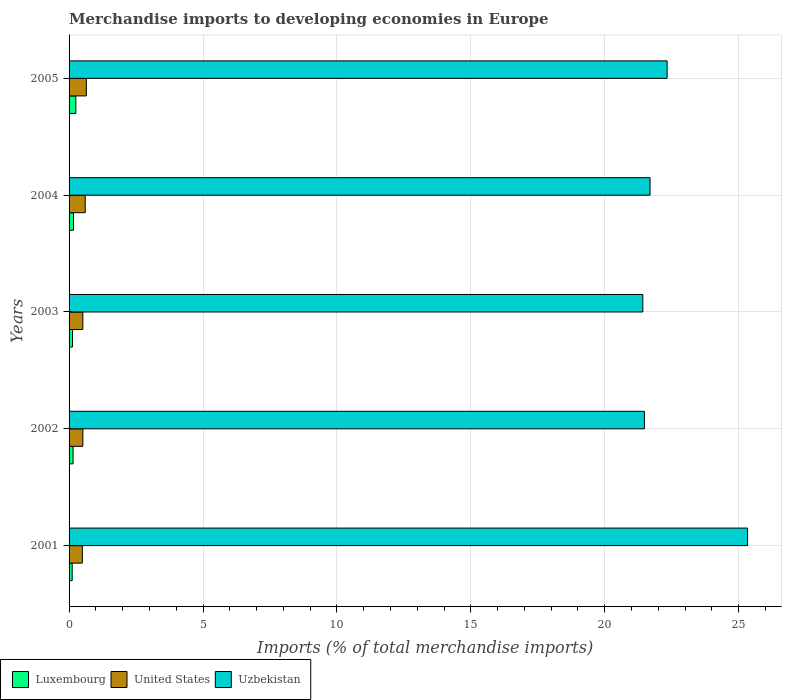Are the number of bars per tick equal to the number of legend labels?
Offer a very short reply. Yes. How many bars are there on the 3rd tick from the bottom?
Your response must be concise. 3. In how many cases, is the number of bars for a given year not equal to the number of legend labels?
Give a very brief answer. 0. What is the percentage total merchandise imports in Luxembourg in 2001?
Offer a very short reply. 0.12. Across all years, what is the maximum percentage total merchandise imports in United States?
Make the answer very short. 0.65. Across all years, what is the minimum percentage total merchandise imports in United States?
Give a very brief answer. 0.5. In which year was the percentage total merchandise imports in United States maximum?
Your answer should be compact. 2005. What is the total percentage total merchandise imports in United States in the graph?
Your response must be concise. 2.77. What is the difference between the percentage total merchandise imports in United States in 2001 and that in 2002?
Make the answer very short. -0.02. What is the difference between the percentage total merchandise imports in Luxembourg in 2001 and the percentage total merchandise imports in United States in 2002?
Give a very brief answer. -0.4. What is the average percentage total merchandise imports in United States per year?
Your response must be concise. 0.55. In the year 2002, what is the difference between the percentage total merchandise imports in Luxembourg and percentage total merchandise imports in United States?
Your answer should be compact. -0.37. What is the ratio of the percentage total merchandise imports in Uzbekistan in 2001 to that in 2004?
Give a very brief answer. 1.17. Is the difference between the percentage total merchandise imports in Luxembourg in 2002 and 2005 greater than the difference between the percentage total merchandise imports in United States in 2002 and 2005?
Offer a terse response. Yes. What is the difference between the highest and the second highest percentage total merchandise imports in Uzbekistan?
Offer a very short reply. 3. What is the difference between the highest and the lowest percentage total merchandise imports in Uzbekistan?
Your answer should be very brief. 3.91. In how many years, is the percentage total merchandise imports in Uzbekistan greater than the average percentage total merchandise imports in Uzbekistan taken over all years?
Offer a very short reply. 1. Is the sum of the percentage total merchandise imports in United States in 2001 and 2002 greater than the maximum percentage total merchandise imports in Luxembourg across all years?
Offer a terse response. Yes. What does the 3rd bar from the top in 2003 represents?
Your answer should be compact. Luxembourg. What does the 1st bar from the bottom in 2003 represents?
Your answer should be very brief. Luxembourg. How many bars are there?
Give a very brief answer. 15. Are all the bars in the graph horizontal?
Your answer should be compact. Yes. Does the graph contain any zero values?
Your answer should be compact. No. Where does the legend appear in the graph?
Ensure brevity in your answer.  Bottom left. What is the title of the graph?
Your answer should be compact. Merchandise imports to developing economies in Europe. What is the label or title of the X-axis?
Offer a terse response. Imports (% of total merchandise imports). What is the label or title of the Y-axis?
Give a very brief answer. Years. What is the Imports (% of total merchandise imports) of Luxembourg in 2001?
Keep it short and to the point. 0.12. What is the Imports (% of total merchandise imports) of United States in 2001?
Provide a short and direct response. 0.5. What is the Imports (% of total merchandise imports) of Uzbekistan in 2001?
Your answer should be very brief. 25.33. What is the Imports (% of total merchandise imports) in Luxembourg in 2002?
Offer a terse response. 0.15. What is the Imports (% of total merchandise imports) in United States in 2002?
Your response must be concise. 0.52. What is the Imports (% of total merchandise imports) of Uzbekistan in 2002?
Your answer should be very brief. 21.48. What is the Imports (% of total merchandise imports) of Luxembourg in 2003?
Offer a very short reply. 0.13. What is the Imports (% of total merchandise imports) in United States in 2003?
Offer a terse response. 0.51. What is the Imports (% of total merchandise imports) of Uzbekistan in 2003?
Provide a succinct answer. 21.42. What is the Imports (% of total merchandise imports) of Luxembourg in 2004?
Your answer should be compact. 0.16. What is the Imports (% of total merchandise imports) in United States in 2004?
Provide a succinct answer. 0.6. What is the Imports (% of total merchandise imports) of Uzbekistan in 2004?
Ensure brevity in your answer.  21.69. What is the Imports (% of total merchandise imports) of Luxembourg in 2005?
Give a very brief answer. 0.25. What is the Imports (% of total merchandise imports) of United States in 2005?
Provide a succinct answer. 0.65. What is the Imports (% of total merchandise imports) in Uzbekistan in 2005?
Ensure brevity in your answer.  22.33. Across all years, what is the maximum Imports (% of total merchandise imports) of Luxembourg?
Make the answer very short. 0.25. Across all years, what is the maximum Imports (% of total merchandise imports) in United States?
Provide a succinct answer. 0.65. Across all years, what is the maximum Imports (% of total merchandise imports) of Uzbekistan?
Offer a very short reply. 25.33. Across all years, what is the minimum Imports (% of total merchandise imports) of Luxembourg?
Make the answer very short. 0.12. Across all years, what is the minimum Imports (% of total merchandise imports) of United States?
Your answer should be very brief. 0.5. Across all years, what is the minimum Imports (% of total merchandise imports) in Uzbekistan?
Make the answer very short. 21.42. What is the total Imports (% of total merchandise imports) in Luxembourg in the graph?
Your answer should be very brief. 0.81. What is the total Imports (% of total merchandise imports) of United States in the graph?
Ensure brevity in your answer.  2.77. What is the total Imports (% of total merchandise imports) in Uzbekistan in the graph?
Your answer should be very brief. 112.25. What is the difference between the Imports (% of total merchandise imports) in Luxembourg in 2001 and that in 2002?
Your answer should be very brief. -0.03. What is the difference between the Imports (% of total merchandise imports) in United States in 2001 and that in 2002?
Offer a terse response. -0.02. What is the difference between the Imports (% of total merchandise imports) of Uzbekistan in 2001 and that in 2002?
Keep it short and to the point. 3.85. What is the difference between the Imports (% of total merchandise imports) of Luxembourg in 2001 and that in 2003?
Your response must be concise. -0.01. What is the difference between the Imports (% of total merchandise imports) of United States in 2001 and that in 2003?
Your answer should be compact. -0.02. What is the difference between the Imports (% of total merchandise imports) of Uzbekistan in 2001 and that in 2003?
Provide a short and direct response. 3.91. What is the difference between the Imports (% of total merchandise imports) in Luxembourg in 2001 and that in 2004?
Your response must be concise. -0.05. What is the difference between the Imports (% of total merchandise imports) in United States in 2001 and that in 2004?
Offer a terse response. -0.11. What is the difference between the Imports (% of total merchandise imports) of Uzbekistan in 2001 and that in 2004?
Your answer should be very brief. 3.64. What is the difference between the Imports (% of total merchandise imports) in Luxembourg in 2001 and that in 2005?
Your answer should be compact. -0.14. What is the difference between the Imports (% of total merchandise imports) of United States in 2001 and that in 2005?
Your response must be concise. -0.15. What is the difference between the Imports (% of total merchandise imports) in Uzbekistan in 2001 and that in 2005?
Give a very brief answer. 3. What is the difference between the Imports (% of total merchandise imports) in Luxembourg in 2002 and that in 2003?
Provide a succinct answer. 0.02. What is the difference between the Imports (% of total merchandise imports) of United States in 2002 and that in 2003?
Provide a succinct answer. 0. What is the difference between the Imports (% of total merchandise imports) in Uzbekistan in 2002 and that in 2003?
Give a very brief answer. 0.06. What is the difference between the Imports (% of total merchandise imports) in Luxembourg in 2002 and that in 2004?
Offer a terse response. -0.02. What is the difference between the Imports (% of total merchandise imports) in United States in 2002 and that in 2004?
Keep it short and to the point. -0.09. What is the difference between the Imports (% of total merchandise imports) in Uzbekistan in 2002 and that in 2004?
Your answer should be compact. -0.21. What is the difference between the Imports (% of total merchandise imports) of Luxembourg in 2002 and that in 2005?
Provide a succinct answer. -0.1. What is the difference between the Imports (% of total merchandise imports) of United States in 2002 and that in 2005?
Your answer should be very brief. -0.13. What is the difference between the Imports (% of total merchandise imports) in Uzbekistan in 2002 and that in 2005?
Offer a terse response. -0.85. What is the difference between the Imports (% of total merchandise imports) in Luxembourg in 2003 and that in 2004?
Your response must be concise. -0.04. What is the difference between the Imports (% of total merchandise imports) of United States in 2003 and that in 2004?
Offer a terse response. -0.09. What is the difference between the Imports (% of total merchandise imports) of Uzbekistan in 2003 and that in 2004?
Make the answer very short. -0.27. What is the difference between the Imports (% of total merchandise imports) in Luxembourg in 2003 and that in 2005?
Provide a succinct answer. -0.12. What is the difference between the Imports (% of total merchandise imports) in United States in 2003 and that in 2005?
Provide a succinct answer. -0.13. What is the difference between the Imports (% of total merchandise imports) in Uzbekistan in 2003 and that in 2005?
Your answer should be very brief. -0.91. What is the difference between the Imports (% of total merchandise imports) of Luxembourg in 2004 and that in 2005?
Offer a very short reply. -0.09. What is the difference between the Imports (% of total merchandise imports) of United States in 2004 and that in 2005?
Your answer should be compact. -0.04. What is the difference between the Imports (% of total merchandise imports) in Uzbekistan in 2004 and that in 2005?
Keep it short and to the point. -0.64. What is the difference between the Imports (% of total merchandise imports) of Luxembourg in 2001 and the Imports (% of total merchandise imports) of United States in 2002?
Your answer should be very brief. -0.4. What is the difference between the Imports (% of total merchandise imports) in Luxembourg in 2001 and the Imports (% of total merchandise imports) in Uzbekistan in 2002?
Give a very brief answer. -21.36. What is the difference between the Imports (% of total merchandise imports) in United States in 2001 and the Imports (% of total merchandise imports) in Uzbekistan in 2002?
Provide a short and direct response. -20.99. What is the difference between the Imports (% of total merchandise imports) in Luxembourg in 2001 and the Imports (% of total merchandise imports) in United States in 2003?
Ensure brevity in your answer.  -0.4. What is the difference between the Imports (% of total merchandise imports) in Luxembourg in 2001 and the Imports (% of total merchandise imports) in Uzbekistan in 2003?
Offer a terse response. -21.3. What is the difference between the Imports (% of total merchandise imports) of United States in 2001 and the Imports (% of total merchandise imports) of Uzbekistan in 2003?
Provide a succinct answer. -20.93. What is the difference between the Imports (% of total merchandise imports) of Luxembourg in 2001 and the Imports (% of total merchandise imports) of United States in 2004?
Offer a terse response. -0.49. What is the difference between the Imports (% of total merchandise imports) in Luxembourg in 2001 and the Imports (% of total merchandise imports) in Uzbekistan in 2004?
Offer a very short reply. -21.57. What is the difference between the Imports (% of total merchandise imports) of United States in 2001 and the Imports (% of total merchandise imports) of Uzbekistan in 2004?
Provide a short and direct response. -21.2. What is the difference between the Imports (% of total merchandise imports) in Luxembourg in 2001 and the Imports (% of total merchandise imports) in United States in 2005?
Your answer should be compact. -0.53. What is the difference between the Imports (% of total merchandise imports) of Luxembourg in 2001 and the Imports (% of total merchandise imports) of Uzbekistan in 2005?
Ensure brevity in your answer.  -22.21. What is the difference between the Imports (% of total merchandise imports) in United States in 2001 and the Imports (% of total merchandise imports) in Uzbekistan in 2005?
Your response must be concise. -21.83. What is the difference between the Imports (% of total merchandise imports) in Luxembourg in 2002 and the Imports (% of total merchandise imports) in United States in 2003?
Offer a very short reply. -0.36. What is the difference between the Imports (% of total merchandise imports) in Luxembourg in 2002 and the Imports (% of total merchandise imports) in Uzbekistan in 2003?
Give a very brief answer. -21.27. What is the difference between the Imports (% of total merchandise imports) in United States in 2002 and the Imports (% of total merchandise imports) in Uzbekistan in 2003?
Ensure brevity in your answer.  -20.91. What is the difference between the Imports (% of total merchandise imports) of Luxembourg in 2002 and the Imports (% of total merchandise imports) of United States in 2004?
Make the answer very short. -0.45. What is the difference between the Imports (% of total merchandise imports) in Luxembourg in 2002 and the Imports (% of total merchandise imports) in Uzbekistan in 2004?
Keep it short and to the point. -21.54. What is the difference between the Imports (% of total merchandise imports) in United States in 2002 and the Imports (% of total merchandise imports) in Uzbekistan in 2004?
Make the answer very short. -21.18. What is the difference between the Imports (% of total merchandise imports) in Luxembourg in 2002 and the Imports (% of total merchandise imports) in United States in 2005?
Offer a terse response. -0.5. What is the difference between the Imports (% of total merchandise imports) in Luxembourg in 2002 and the Imports (% of total merchandise imports) in Uzbekistan in 2005?
Make the answer very short. -22.18. What is the difference between the Imports (% of total merchandise imports) in United States in 2002 and the Imports (% of total merchandise imports) in Uzbekistan in 2005?
Give a very brief answer. -21.81. What is the difference between the Imports (% of total merchandise imports) of Luxembourg in 2003 and the Imports (% of total merchandise imports) of United States in 2004?
Make the answer very short. -0.47. What is the difference between the Imports (% of total merchandise imports) of Luxembourg in 2003 and the Imports (% of total merchandise imports) of Uzbekistan in 2004?
Give a very brief answer. -21.56. What is the difference between the Imports (% of total merchandise imports) of United States in 2003 and the Imports (% of total merchandise imports) of Uzbekistan in 2004?
Offer a very short reply. -21.18. What is the difference between the Imports (% of total merchandise imports) in Luxembourg in 2003 and the Imports (% of total merchandise imports) in United States in 2005?
Ensure brevity in your answer.  -0.52. What is the difference between the Imports (% of total merchandise imports) of Luxembourg in 2003 and the Imports (% of total merchandise imports) of Uzbekistan in 2005?
Make the answer very short. -22.2. What is the difference between the Imports (% of total merchandise imports) of United States in 2003 and the Imports (% of total merchandise imports) of Uzbekistan in 2005?
Give a very brief answer. -21.81. What is the difference between the Imports (% of total merchandise imports) in Luxembourg in 2004 and the Imports (% of total merchandise imports) in United States in 2005?
Offer a very short reply. -0.48. What is the difference between the Imports (% of total merchandise imports) in Luxembourg in 2004 and the Imports (% of total merchandise imports) in Uzbekistan in 2005?
Your answer should be compact. -22.16. What is the difference between the Imports (% of total merchandise imports) in United States in 2004 and the Imports (% of total merchandise imports) in Uzbekistan in 2005?
Provide a short and direct response. -21.73. What is the average Imports (% of total merchandise imports) in Luxembourg per year?
Your answer should be compact. 0.16. What is the average Imports (% of total merchandise imports) of United States per year?
Your answer should be compact. 0.55. What is the average Imports (% of total merchandise imports) of Uzbekistan per year?
Offer a terse response. 22.45. In the year 2001, what is the difference between the Imports (% of total merchandise imports) in Luxembourg and Imports (% of total merchandise imports) in United States?
Keep it short and to the point. -0.38. In the year 2001, what is the difference between the Imports (% of total merchandise imports) in Luxembourg and Imports (% of total merchandise imports) in Uzbekistan?
Give a very brief answer. -25.22. In the year 2001, what is the difference between the Imports (% of total merchandise imports) of United States and Imports (% of total merchandise imports) of Uzbekistan?
Give a very brief answer. -24.84. In the year 2002, what is the difference between the Imports (% of total merchandise imports) in Luxembourg and Imports (% of total merchandise imports) in United States?
Your answer should be compact. -0.37. In the year 2002, what is the difference between the Imports (% of total merchandise imports) in Luxembourg and Imports (% of total merchandise imports) in Uzbekistan?
Make the answer very short. -21.33. In the year 2002, what is the difference between the Imports (% of total merchandise imports) of United States and Imports (% of total merchandise imports) of Uzbekistan?
Keep it short and to the point. -20.97. In the year 2003, what is the difference between the Imports (% of total merchandise imports) in Luxembourg and Imports (% of total merchandise imports) in United States?
Your answer should be compact. -0.38. In the year 2003, what is the difference between the Imports (% of total merchandise imports) of Luxembourg and Imports (% of total merchandise imports) of Uzbekistan?
Offer a terse response. -21.29. In the year 2003, what is the difference between the Imports (% of total merchandise imports) of United States and Imports (% of total merchandise imports) of Uzbekistan?
Your answer should be very brief. -20.91. In the year 2004, what is the difference between the Imports (% of total merchandise imports) of Luxembourg and Imports (% of total merchandise imports) of United States?
Keep it short and to the point. -0.44. In the year 2004, what is the difference between the Imports (% of total merchandise imports) of Luxembourg and Imports (% of total merchandise imports) of Uzbekistan?
Make the answer very short. -21.53. In the year 2004, what is the difference between the Imports (% of total merchandise imports) of United States and Imports (% of total merchandise imports) of Uzbekistan?
Offer a very short reply. -21.09. In the year 2005, what is the difference between the Imports (% of total merchandise imports) in Luxembourg and Imports (% of total merchandise imports) in United States?
Offer a very short reply. -0.39. In the year 2005, what is the difference between the Imports (% of total merchandise imports) in Luxembourg and Imports (% of total merchandise imports) in Uzbekistan?
Ensure brevity in your answer.  -22.08. In the year 2005, what is the difference between the Imports (% of total merchandise imports) in United States and Imports (% of total merchandise imports) in Uzbekistan?
Your response must be concise. -21.68. What is the ratio of the Imports (% of total merchandise imports) in Luxembourg in 2001 to that in 2002?
Make the answer very short. 0.78. What is the ratio of the Imports (% of total merchandise imports) in United States in 2001 to that in 2002?
Provide a short and direct response. 0.96. What is the ratio of the Imports (% of total merchandise imports) in Uzbekistan in 2001 to that in 2002?
Provide a short and direct response. 1.18. What is the ratio of the Imports (% of total merchandise imports) of Luxembourg in 2001 to that in 2003?
Give a very brief answer. 0.9. What is the ratio of the Imports (% of total merchandise imports) in United States in 2001 to that in 2003?
Your response must be concise. 0.96. What is the ratio of the Imports (% of total merchandise imports) of Uzbekistan in 2001 to that in 2003?
Offer a terse response. 1.18. What is the ratio of the Imports (% of total merchandise imports) in Luxembourg in 2001 to that in 2004?
Give a very brief answer. 0.71. What is the ratio of the Imports (% of total merchandise imports) in United States in 2001 to that in 2004?
Provide a short and direct response. 0.82. What is the ratio of the Imports (% of total merchandise imports) in Uzbekistan in 2001 to that in 2004?
Your response must be concise. 1.17. What is the ratio of the Imports (% of total merchandise imports) in Luxembourg in 2001 to that in 2005?
Your answer should be compact. 0.46. What is the ratio of the Imports (% of total merchandise imports) in United States in 2001 to that in 2005?
Offer a very short reply. 0.77. What is the ratio of the Imports (% of total merchandise imports) of Uzbekistan in 2001 to that in 2005?
Give a very brief answer. 1.13. What is the ratio of the Imports (% of total merchandise imports) of Luxembourg in 2002 to that in 2003?
Keep it short and to the point. 1.15. What is the ratio of the Imports (% of total merchandise imports) in Luxembourg in 2002 to that in 2004?
Provide a succinct answer. 0.91. What is the ratio of the Imports (% of total merchandise imports) of United States in 2002 to that in 2004?
Your answer should be compact. 0.85. What is the ratio of the Imports (% of total merchandise imports) in Uzbekistan in 2002 to that in 2004?
Provide a succinct answer. 0.99. What is the ratio of the Imports (% of total merchandise imports) of Luxembourg in 2002 to that in 2005?
Give a very brief answer. 0.59. What is the ratio of the Imports (% of total merchandise imports) in United States in 2002 to that in 2005?
Your answer should be compact. 0.8. What is the ratio of the Imports (% of total merchandise imports) in Uzbekistan in 2002 to that in 2005?
Your answer should be compact. 0.96. What is the ratio of the Imports (% of total merchandise imports) in Luxembourg in 2003 to that in 2004?
Your answer should be compact. 0.78. What is the ratio of the Imports (% of total merchandise imports) in United States in 2003 to that in 2004?
Keep it short and to the point. 0.85. What is the ratio of the Imports (% of total merchandise imports) of Uzbekistan in 2003 to that in 2004?
Your answer should be very brief. 0.99. What is the ratio of the Imports (% of total merchandise imports) of Luxembourg in 2003 to that in 2005?
Provide a succinct answer. 0.51. What is the ratio of the Imports (% of total merchandise imports) in United States in 2003 to that in 2005?
Give a very brief answer. 0.8. What is the ratio of the Imports (% of total merchandise imports) of Uzbekistan in 2003 to that in 2005?
Offer a terse response. 0.96. What is the ratio of the Imports (% of total merchandise imports) of Luxembourg in 2004 to that in 2005?
Ensure brevity in your answer.  0.65. What is the ratio of the Imports (% of total merchandise imports) in United States in 2004 to that in 2005?
Make the answer very short. 0.94. What is the ratio of the Imports (% of total merchandise imports) of Uzbekistan in 2004 to that in 2005?
Your answer should be compact. 0.97. What is the difference between the highest and the second highest Imports (% of total merchandise imports) of Luxembourg?
Make the answer very short. 0.09. What is the difference between the highest and the second highest Imports (% of total merchandise imports) in United States?
Your response must be concise. 0.04. What is the difference between the highest and the second highest Imports (% of total merchandise imports) of Uzbekistan?
Ensure brevity in your answer.  3. What is the difference between the highest and the lowest Imports (% of total merchandise imports) in Luxembourg?
Offer a very short reply. 0.14. What is the difference between the highest and the lowest Imports (% of total merchandise imports) of United States?
Keep it short and to the point. 0.15. What is the difference between the highest and the lowest Imports (% of total merchandise imports) of Uzbekistan?
Offer a terse response. 3.91. 